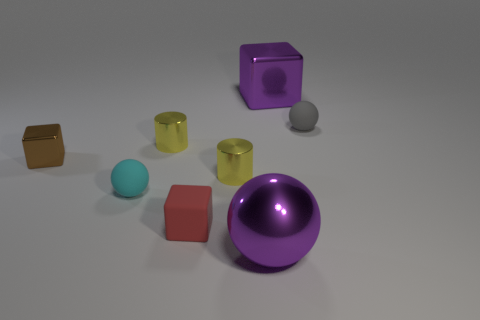Subtract all metallic blocks. How many blocks are left? 1 Subtract 1 cubes. How many cubes are left? 2 Add 1 big red shiny cylinders. How many objects exist? 9 Subtract all cubes. How many objects are left? 5 Add 5 purple objects. How many purple objects are left? 7 Add 8 gray rubber objects. How many gray rubber objects exist? 9 Subtract 0 brown spheres. How many objects are left? 8 Subtract all blocks. Subtract all gray matte things. How many objects are left? 4 